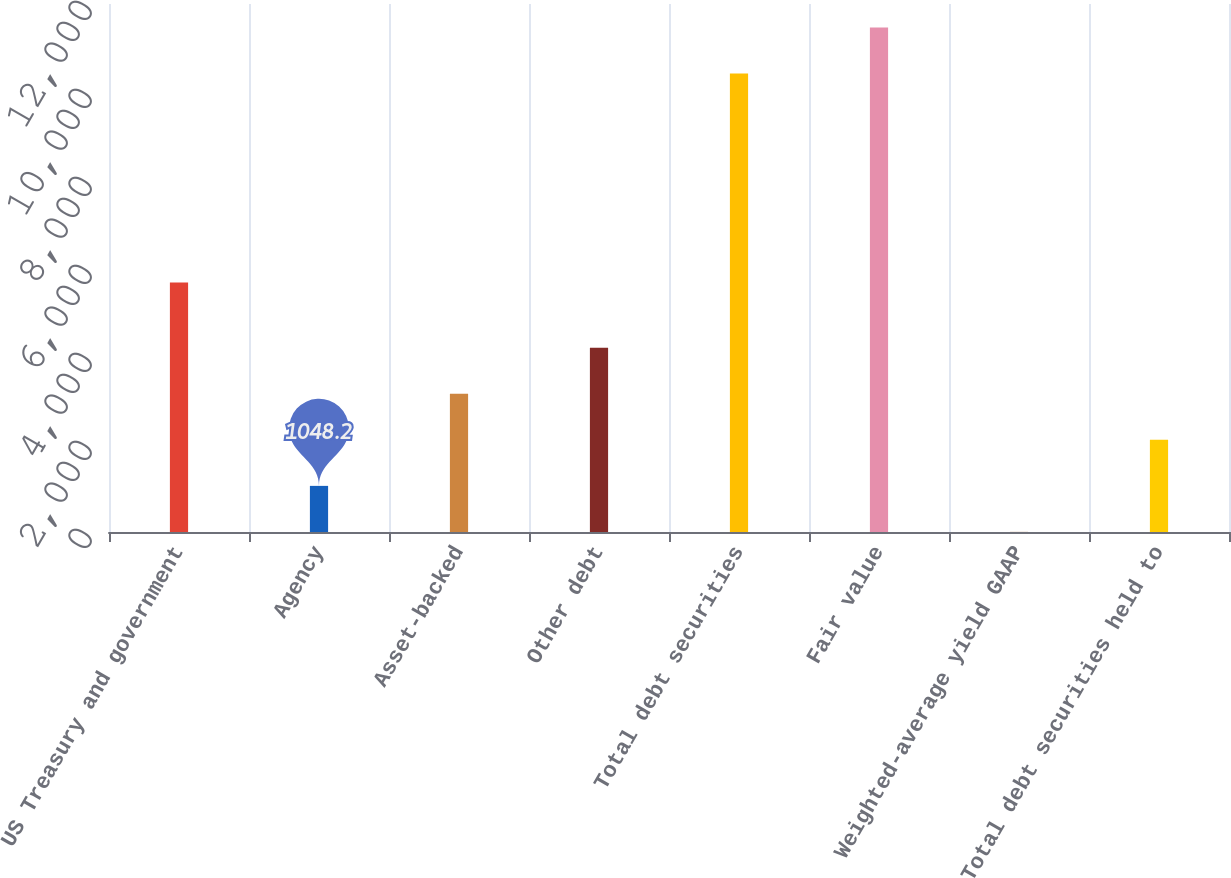Convert chart. <chart><loc_0><loc_0><loc_500><loc_500><bar_chart><fcel>US Treasury and government<fcel>Agency<fcel>Asset-backed<fcel>Other debt<fcel>Total debt securities<fcel>Fair value<fcel>Weighted-average yield GAAP<fcel>Total debt securities held to<nl><fcel>5673<fcel>1048.2<fcel>3140.38<fcel>4186.47<fcel>10421<fcel>11467.1<fcel>2.11<fcel>2094.29<nl></chart> 